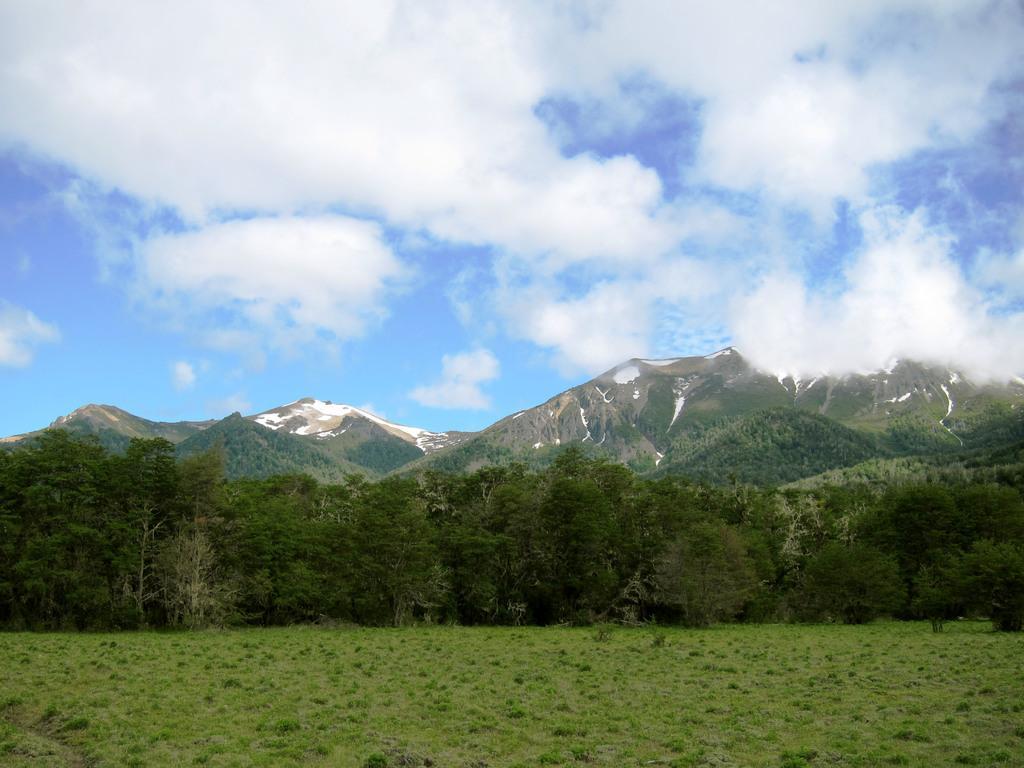Could you give a brief overview of what you see in this image? In this image we can see a group of trees, mountains and in the background, we can see the cloudy sky. 